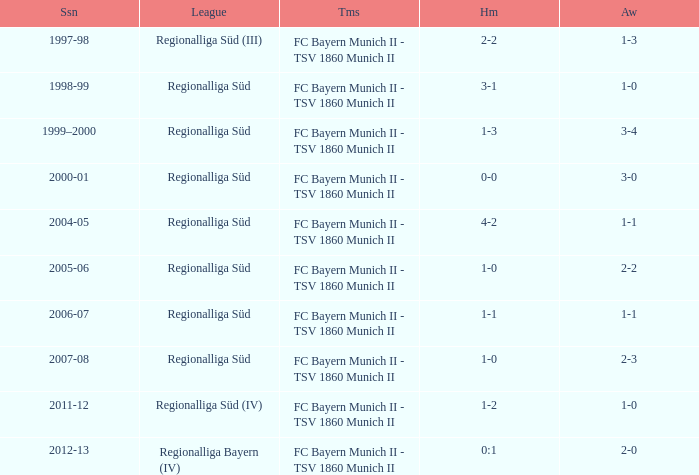Which teams were in the 2006-07 season? FC Bayern Munich II - TSV 1860 Munich II. 